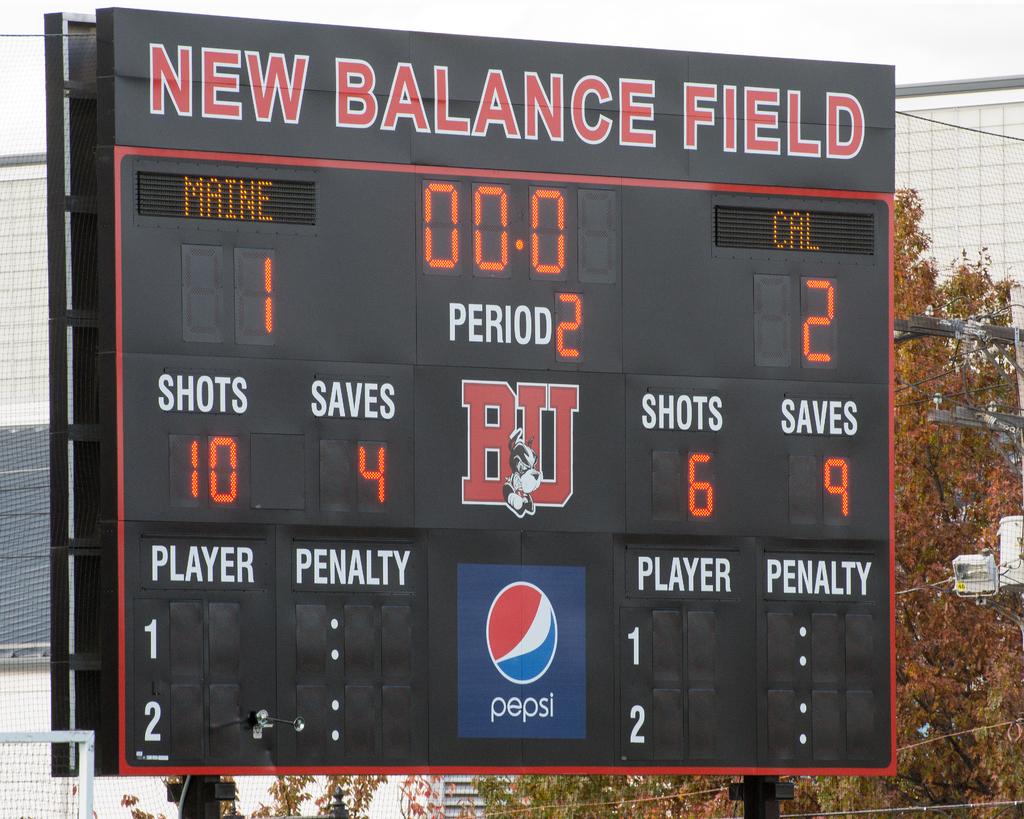What field are they playing at?
Offer a terse response. New balance field. What period is it?
Your answer should be compact. 2. 